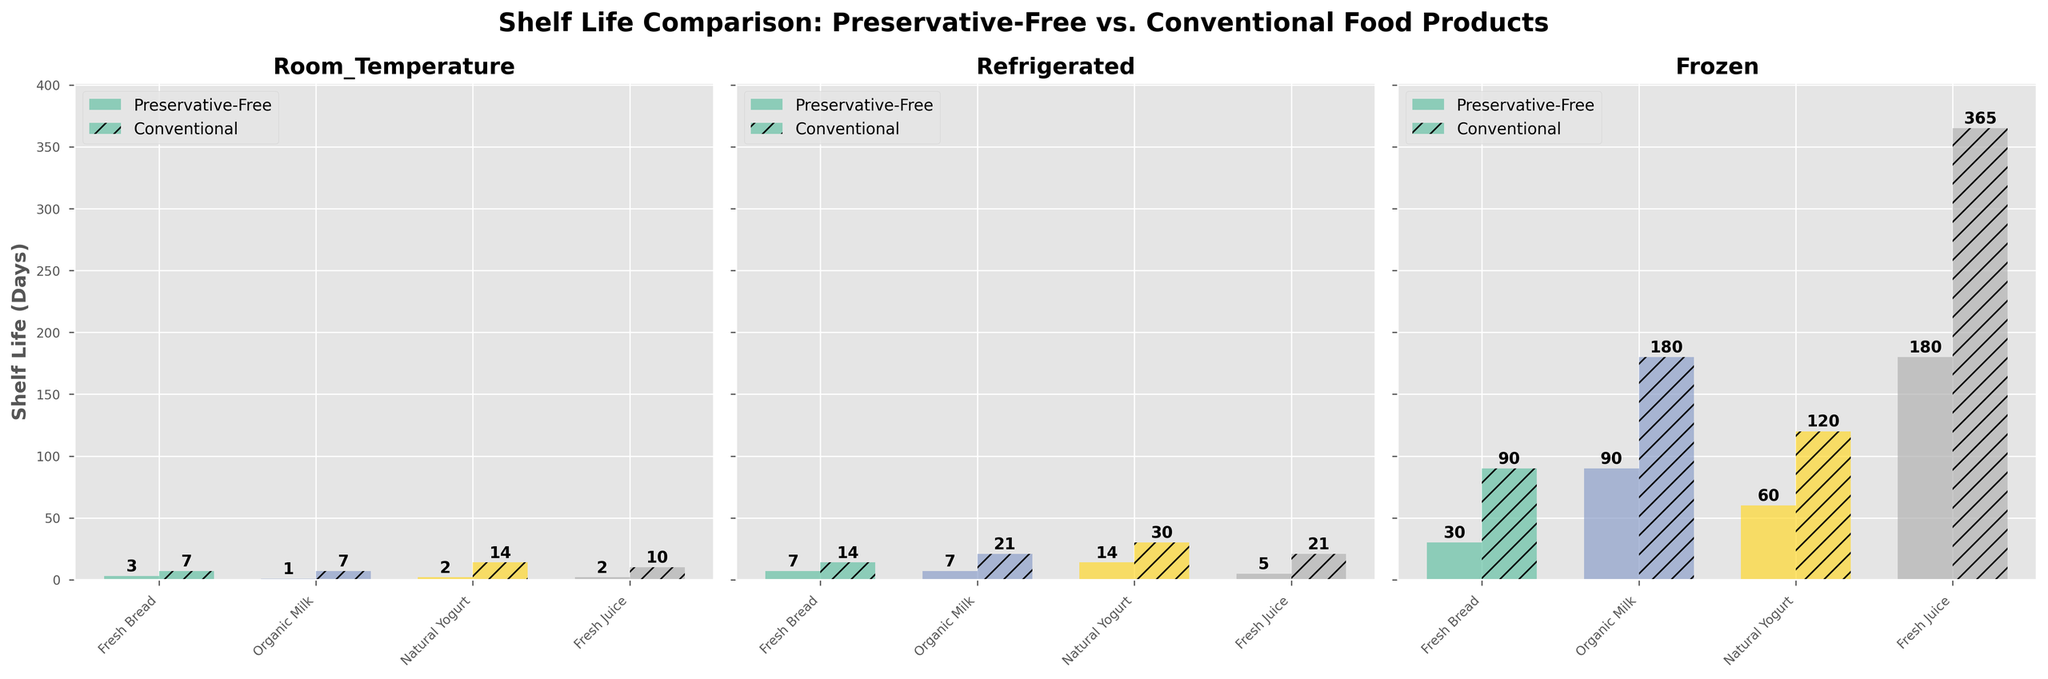What is the title of the figure? The title is found at the top of the figure. The exact text is: "Shelf Life Comparison: Preservative-Free vs. Conventional Food Products".
Answer: Shelf Life Comparison: Preservative-Free vs. Conventional Food Products How many subplots are presented in the figure? Counting the distinct charts in the figure shows that there are three subplots corresponding to Room Temperature, Refrigerated, and Frozen storage conditions.
Answer: Three Which food product has the shortest shelf life when stored at room temperature for preservative-free products? Within the Room Temperature subplot, examine the bars. The shortest bar for preservative-free products represents Organic Milk with a shelf life of 1 day.
Answer: Organic Milk What is the shelf life difference between preservative-free and conventional Fresh Bread when refrigerated? Look at the Refrigerated subplot. The shelf life for preservative-free Fresh Bread is 7 days, and for conventional Fresh Bread, it's 14 days. The difference is 14 - 7.
Answer: 7 days Which storage condition shows the largest difference in shelf life for Fresh Juice between preservative-free and conventional options? Analyze the subplots for Fresh Juice. In Room Temperature, the difference is 10 - 2. In Refrigerated, it's 21 - 5. In Frozen, it's 365 - 180. So the largest difference is in the Frozen condition.
Answer: Frozen What is the average shelf life of Organic Milk for all storage conditions for preservative-free products? Add the shelf lives for preservative-free Organic Milk across Room Temperature, Refrigerated, and Frozen subplots: 1 + 7 + 90. Divide by the number of conditions (3).
Answer: 32.67 days How does the shelf life of preservative-free Natural Yogurt vary from room temperature to frozen conditions? Check the values in the subplots for Natural Yogurt. At Room Temperature, it's 2 days. Refrigerated, it's 14 days. Frozen, it's 60 days. So, 60 - 2.
Answer: Increases by 58 days In which storage condition do all food products have the longest shelf life for preservative-free options? By inspecting the overall height of the preservative-free bars in each condition, it's evident that the Frozen condition consistently has the longest shelf life across all included products.
Answer: Frozen Which conventional food product experiences the greatest absolute increase in shelf life when moving from room temperature to refrigerated storage? Look at the Room Temperature and Refrigerated subplots for conventional products. Calculate the differences for each product. Natural Yogurt goes from 14 to 30 days, the increase is 16 days, which is the highest compared to others.
Answer: Natural Yogurt 